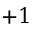<formula> <loc_0><loc_0><loc_500><loc_500>+ 1</formula> 